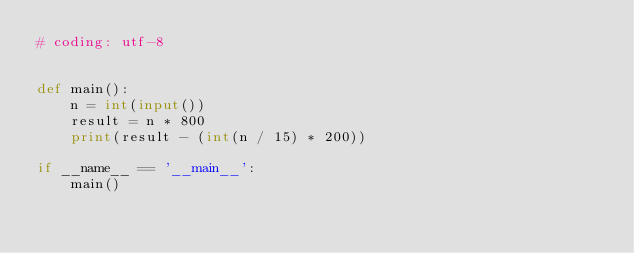Convert code to text. <code><loc_0><loc_0><loc_500><loc_500><_Python_># coding: utf-8


def main():
    n = int(input())
    result = n * 800
    print(result - (int(n / 15) * 200))

if __name__ == '__main__':
    main()</code> 